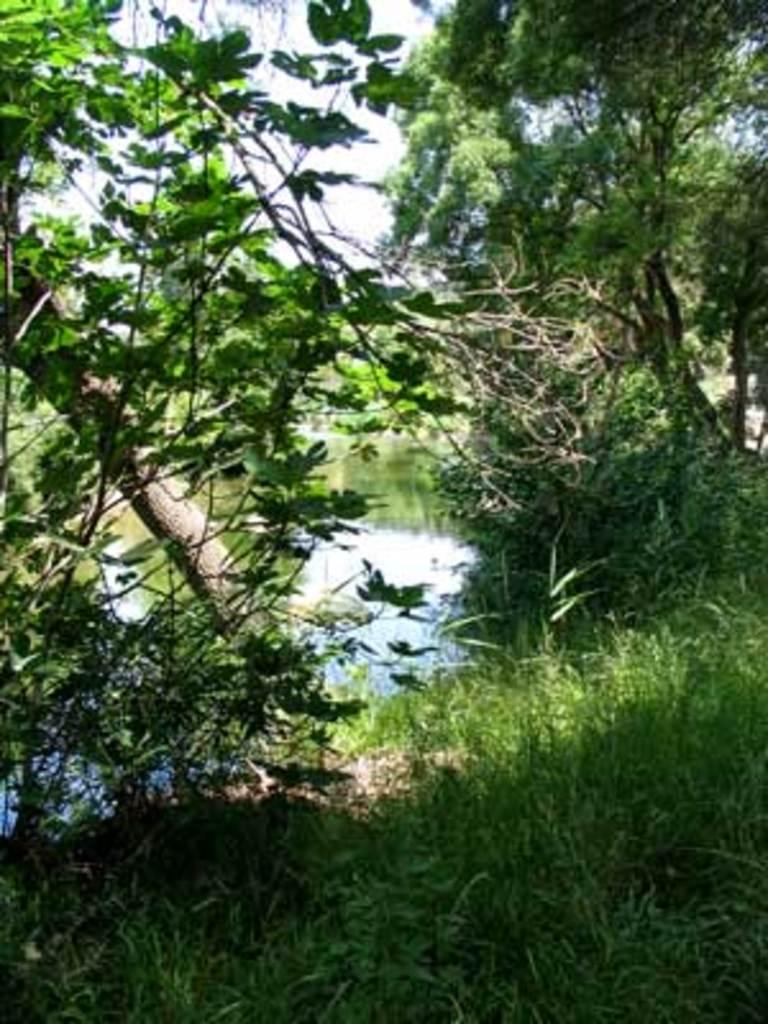What type of vegetation can be seen in the image? There are plants and trees in the image. What is covering the ground in the image? There is grass on the ground in the image. What else can be seen besides vegetation in the image? There is water and the sky visible in the image. How many houses are visible in the image? There are no houses present in the image. What grade is the plant in the image? The image does not indicate the grade or age of the plants. 